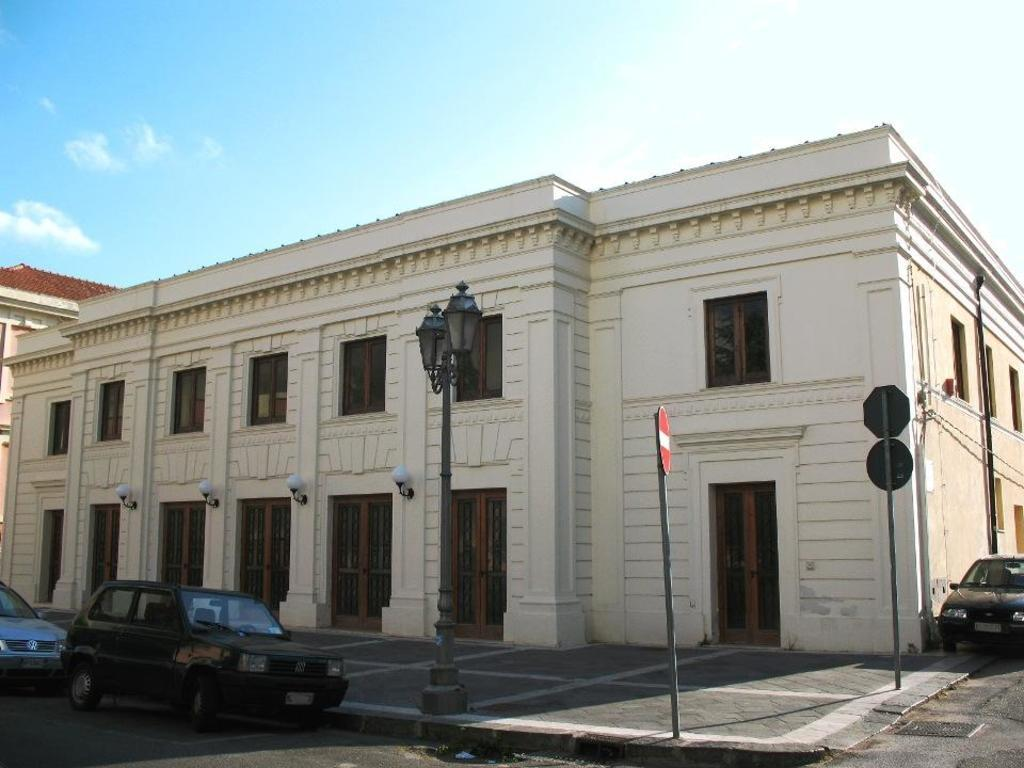What can be seen on the road in the image? There are vehicles on the road in the image. What else is present in the image besides the vehicles? There are lights, boards, poles, buildings, and the sky visible in the image. Can you describe the lights in the image? The lights in the image are likely streetlights or traffic lights. What type of structures can be seen in the image? There are buildings in the image. What is visible in the background of the image? The sky is visible in the background of the image. What type of doll is being used to make a decision in the image? There is no doll present in the image, and therefore no such decision-making process can be observed. What type of selection is being made in the image? There is no selection process depicted in the image. 